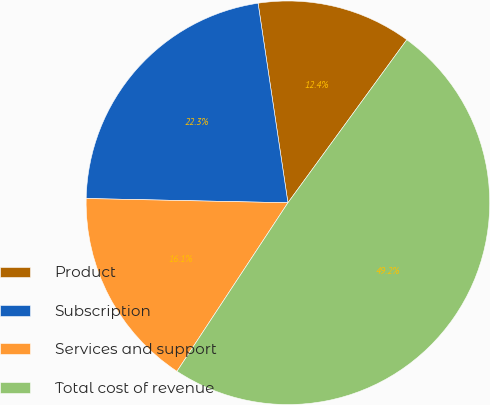<chart> <loc_0><loc_0><loc_500><loc_500><pie_chart><fcel>Product<fcel>Subscription<fcel>Services and support<fcel>Total cost of revenue<nl><fcel>12.39%<fcel>22.3%<fcel>16.07%<fcel>49.24%<nl></chart> 